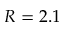Convert formula to latex. <formula><loc_0><loc_0><loc_500><loc_500>R = 2 . 1</formula> 